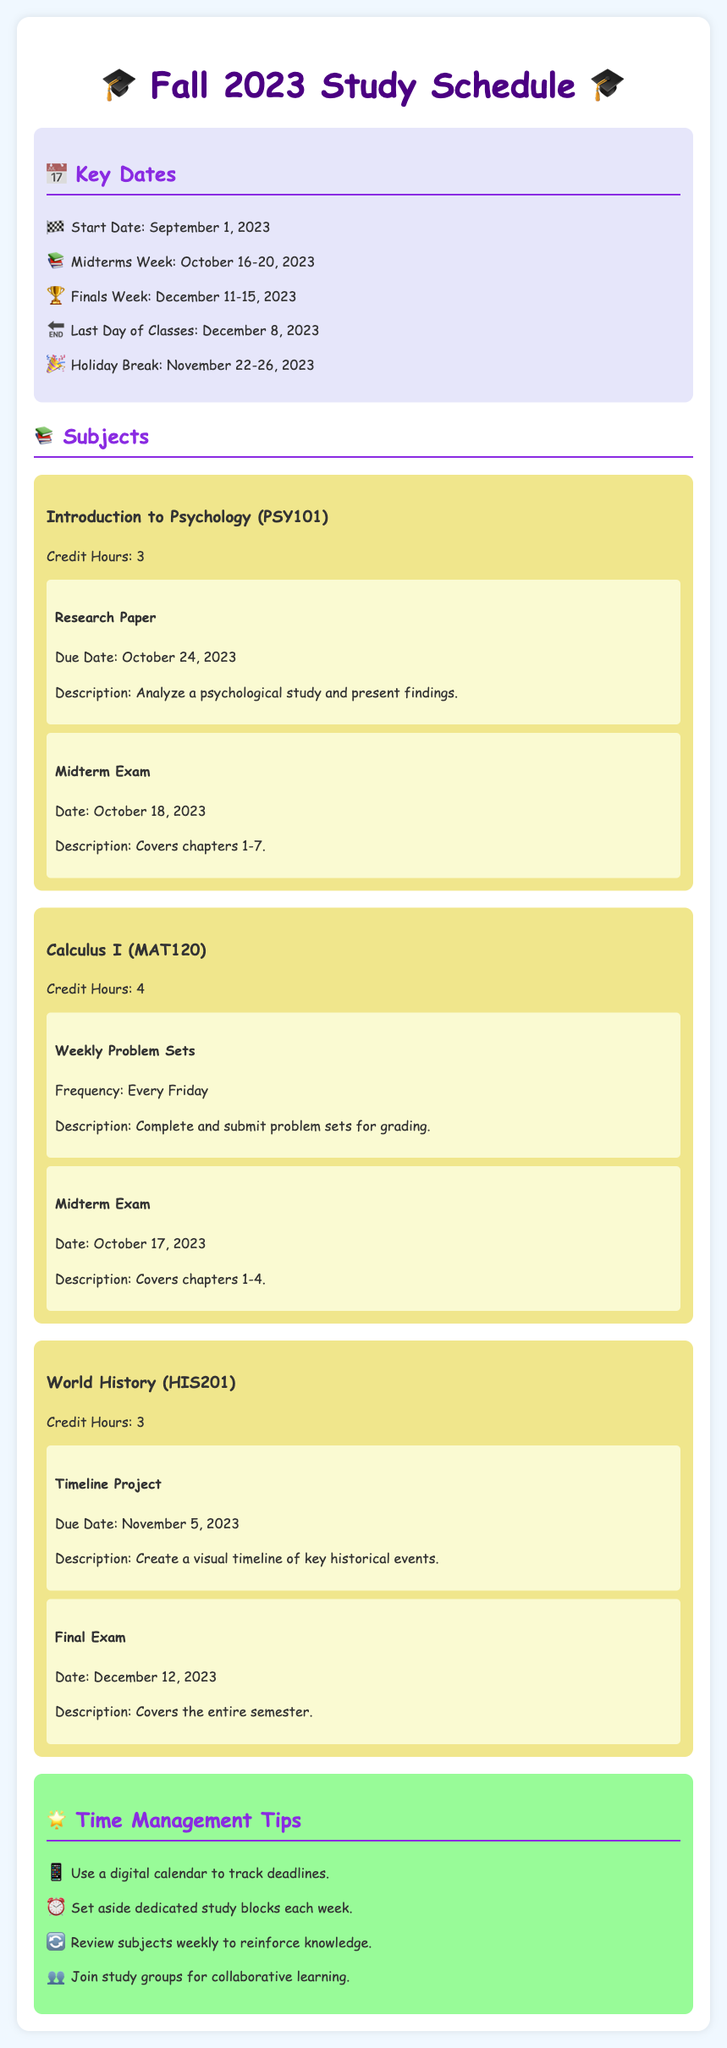What is the start date of the semester? The start date of the semester is specified under key dates in the document.
Answer: September 1, 2023 When is the midterm exam for Calculus I? The midterm exam date for Calculus I is mentioned along with the subject information.
Answer: October 17, 2023 How many credit hours does Introduction to Psychology have? The number of credit hours is listed directly under the subject in the document.
Answer: 3 What project is due for World History? The assignment description for World History includes the project that is due.
Answer: Timeline Project What is the holiday break duration? The holiday break is stated in the key dates section, specifying the exact days.
Answer: November 22-26, 2023 What is recommended for time management? A tip for time management can be found in the tips section.
Answer: Use a digital calendar When is the last day of classes? The last day of classes is noted in the key dates section of the document.
Answer: December 8, 2023 What chapters does the midterm for Introduction to Psychology cover? The midterm exam's coverage chapters are mentioned under the assignment details for that subject.
Answer: Chapters 1-7 How often are the weekly problem sets due for Calculus I? The frequency of the assignments is specified in the assignment details for Calculus I.
Answer: Every Friday 